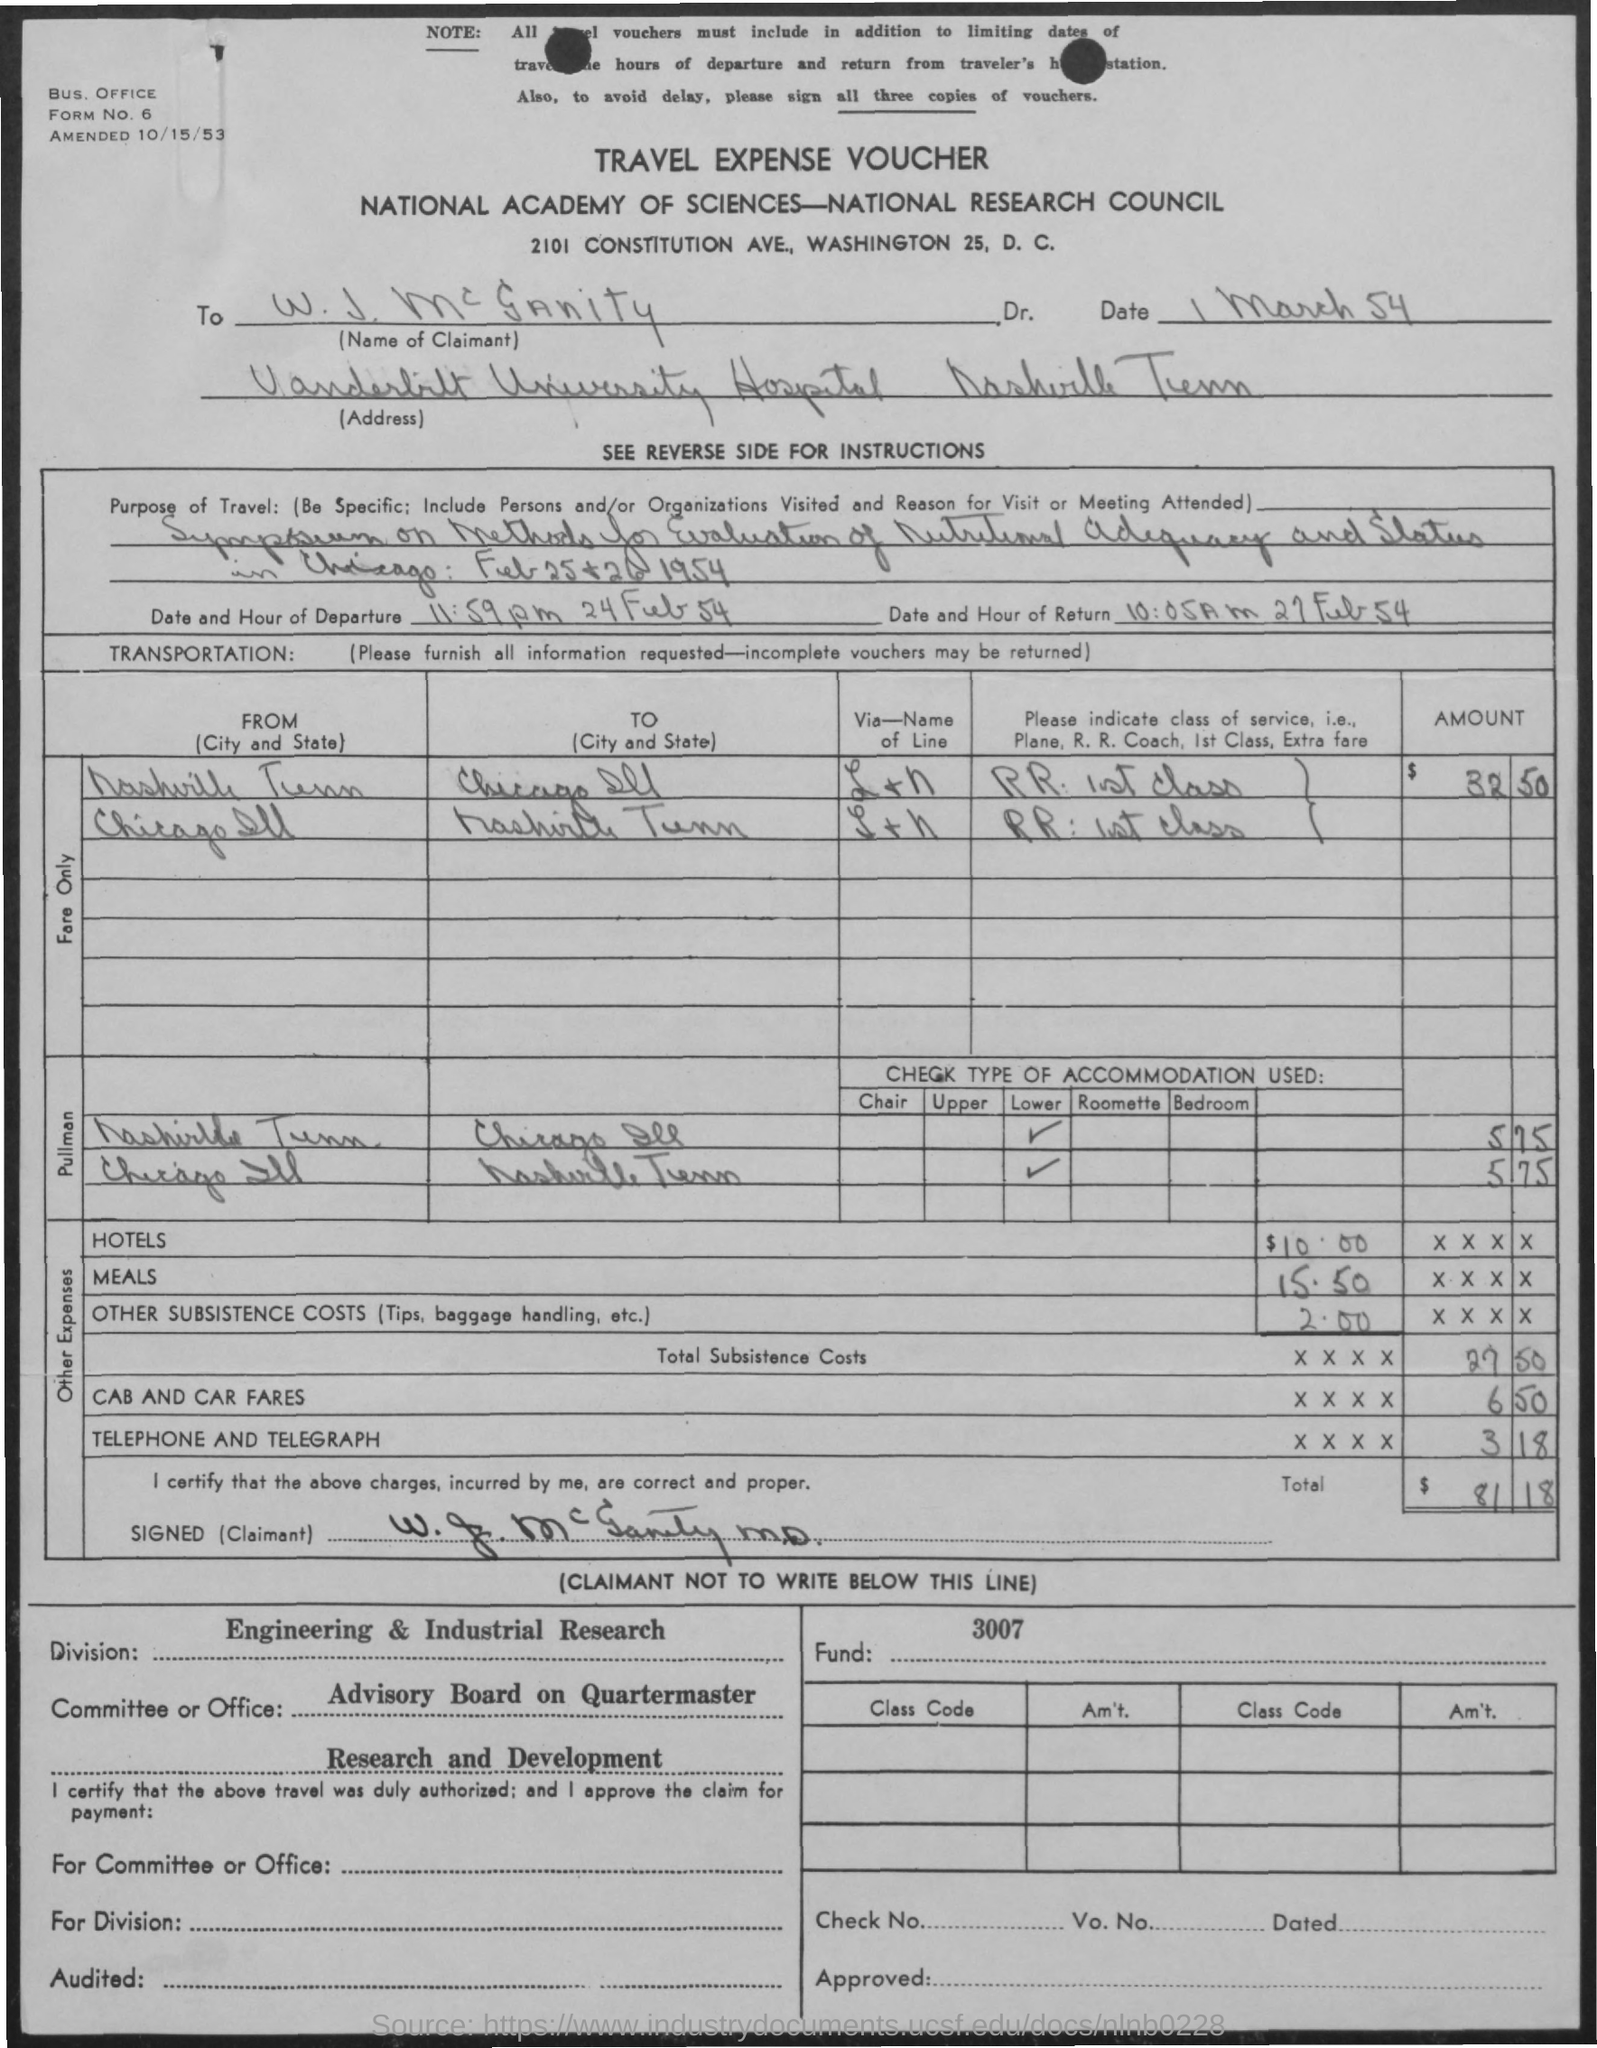Can you tell me to whom the travel expense voucher is made out? The voucher is made out to a Dr. W. J. McCrannity, who appears to have been traveling for research associated with the National Academy of Sciences—National Research Council. 